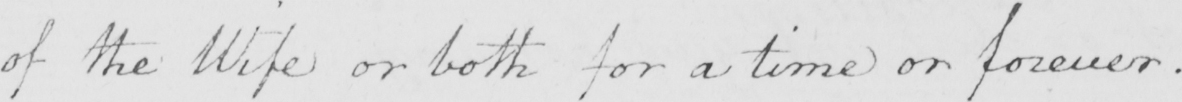Can you tell me what this handwritten text says? of the Wife or both for a time or forever . 